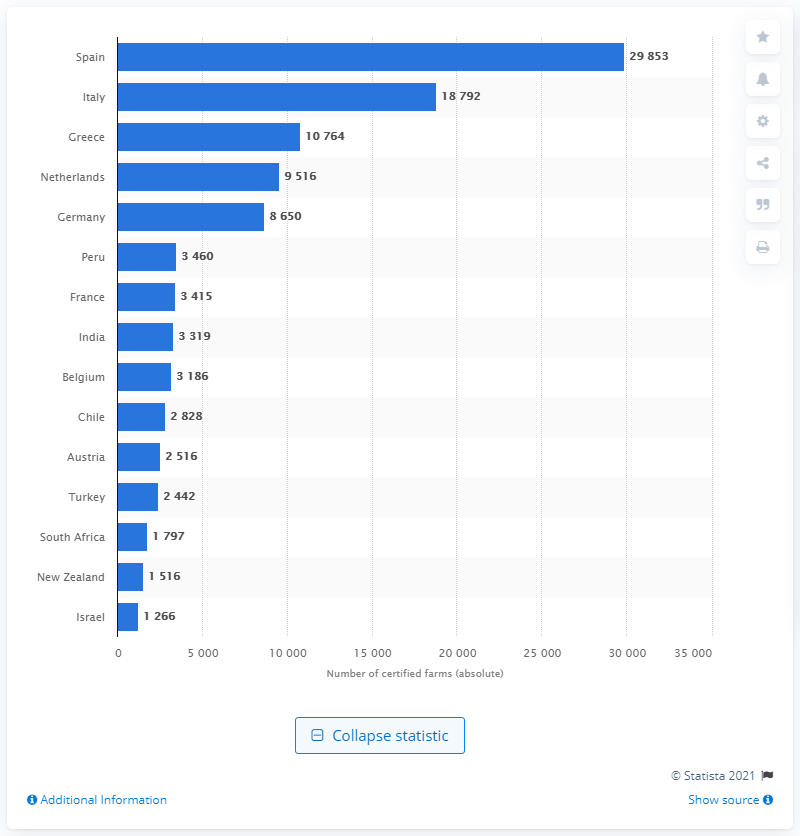Point out several critical features in this image. As of December 2012, there were 18,792 GLOBALG.A.P certified farms in Italy. 